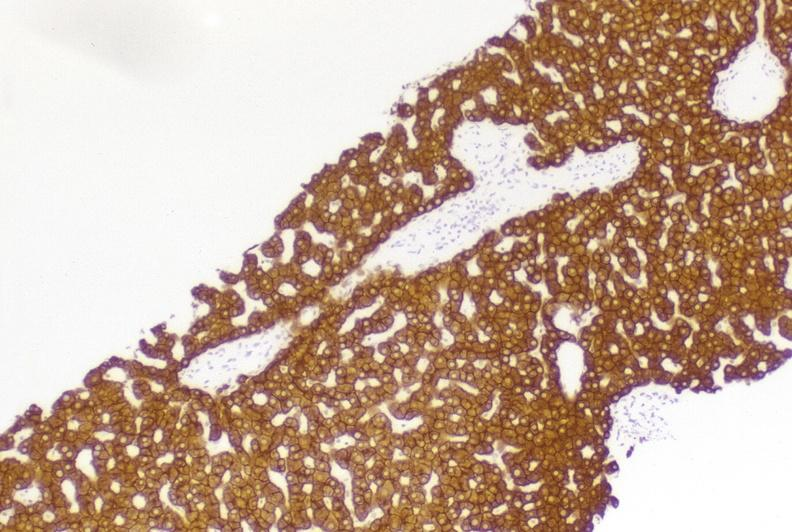s leiomyoma present?
Answer the question using a single word or phrase. No 